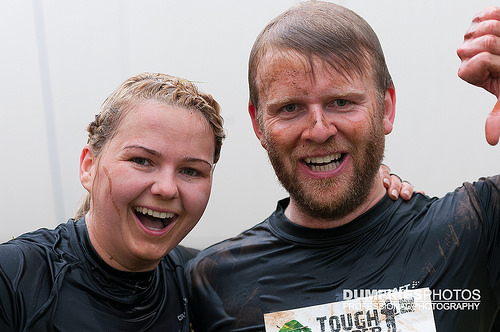<image>
Is there a man on the woman? No. The man is not positioned on the woman. They may be near each other, but the man is not supported by or resting on top of the woman. Is the man to the left of the woman? No. The man is not to the left of the woman. From this viewpoint, they have a different horizontal relationship. 